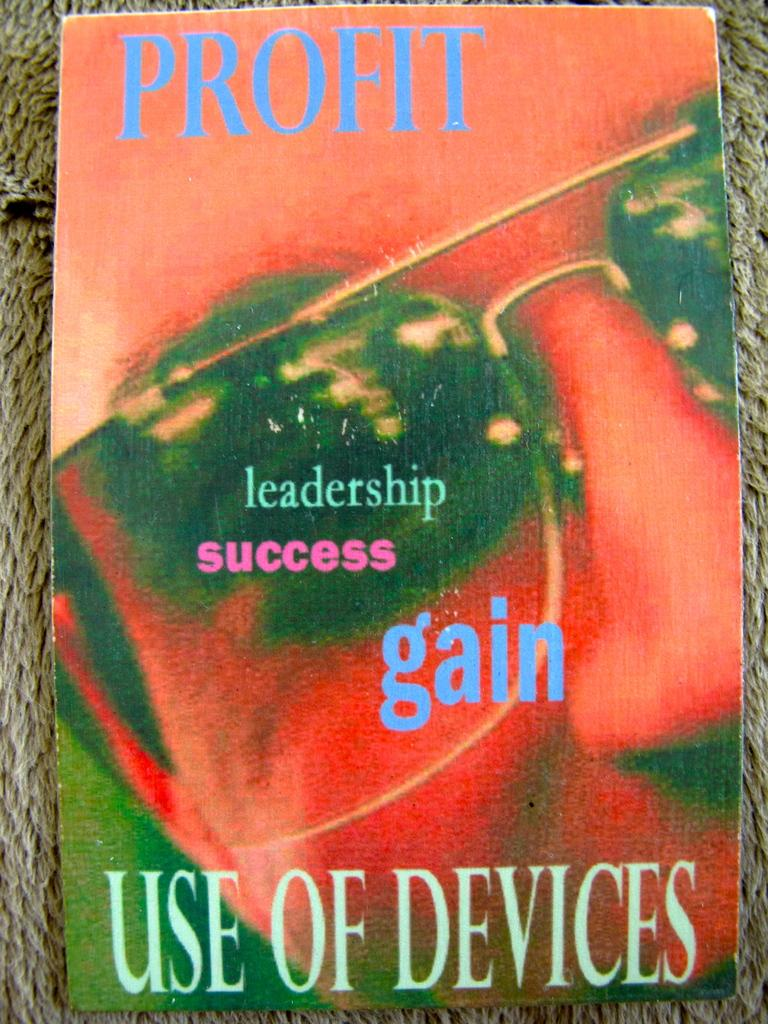<image>
Describe the image concisely. The front cover of a book titled USE OF DEVICES. 